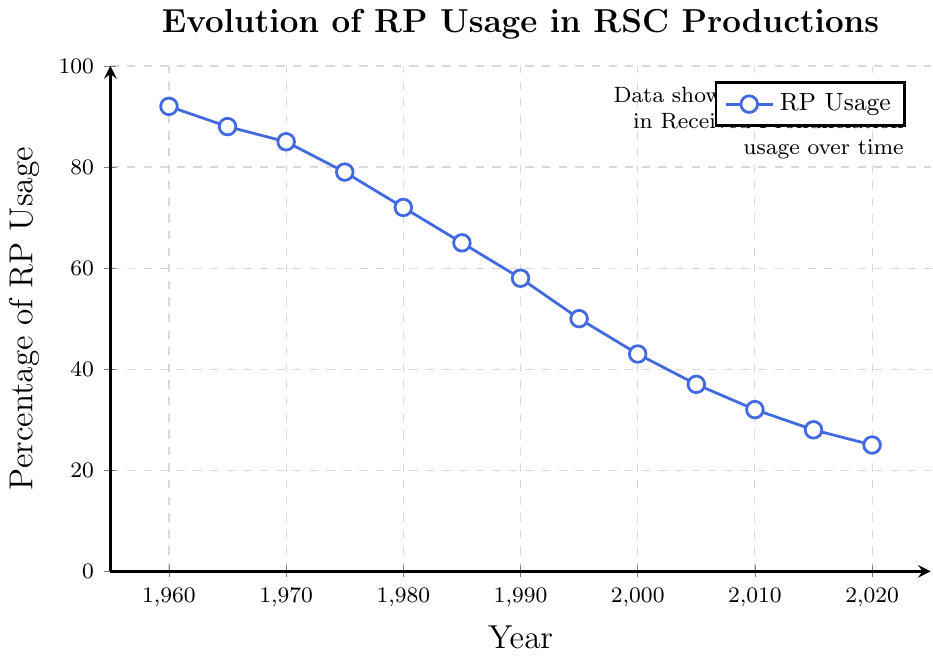What percentage of RP usage was recorded in 1985? From the chart, look at the year 1985 and find the corresponding point, which is at 65%.
Answer: 65% How much did the RP usage decrease from 1960 to 2020? The RP usage in 1960 was 92%, and it decreased to 25% by 2020. Subtract 25 from 92 to find the decrease. 92 - 25 = 67.
Answer: 67% In what year did the RP usage drop below 50%? Identify the first data point where the percentage is less than 50%. That happens in 1995, where it is recorded at 50%.
Answer: 1995 Calculate the average RP usage percentage in the 2000s (2000-2020). Add the percentages for the years 2000, 2005, 2010, 2015, and 2020, then divide by the number of data points: (43 + 37 + 32 + 28 + 25) / 5. The sum is 165, and the count is 5, so the average is 165/5 = 33.
Answer: 33% Which decade showed the largest decline in RP usage? Calculate the decline for each decade. 1960-1970: 92 - 85 = 7, 1970-1980: 85 - 72 = 13, 1980-1990: 72 - 58 = 14, 1990-2000: 58 - 43 = 15, 2000-2010: 43 - 32 = 11, 2010-2020: 32 - 25 = 7. The largest decline occurred between 1990 and 2000.
Answer: 1990-2000 Compare the RP usage between 1975 and 2015. In which year was it higher and by how much? In 1975, the RP usage was 79%. In 2015, it was 28%. Calculate the difference: 79 - 28 = 51. Therefore, the RP usage in 1975 was higher by 51%.
Answer: 1975 by 51% What was the trend of RP usage from 1960 to 2020? The visual trend shows a steady decline over the years from 92% in 1960 to 25% in 2020.
Answer: Steady decline Estimate the range of RP usage over the entire period. Find the maximum and minimum RP usage percentages from the chart. The maximum is 92% in 1960, and the minimum is 25% in 2020. Subtract the minimum from the maximum: 92 - 25 = 67.
Answer: 67% 